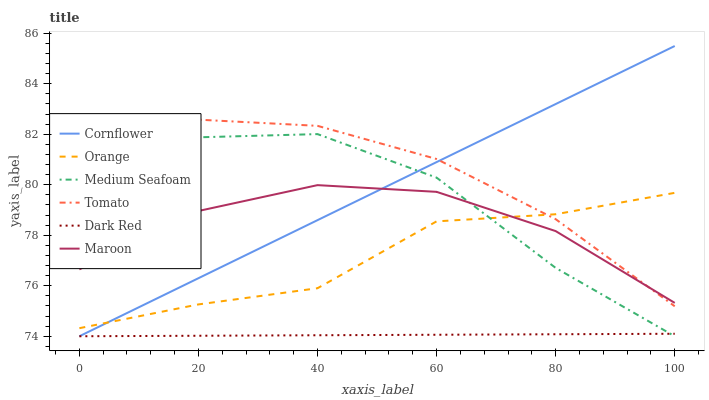Does Dark Red have the minimum area under the curve?
Answer yes or no. Yes. Does Tomato have the maximum area under the curve?
Answer yes or no. Yes. Does Cornflower have the minimum area under the curve?
Answer yes or no. No. Does Cornflower have the maximum area under the curve?
Answer yes or no. No. Is Dark Red the smoothest?
Answer yes or no. Yes. Is Medium Seafoam the roughest?
Answer yes or no. Yes. Is Cornflower the smoothest?
Answer yes or no. No. Is Cornflower the roughest?
Answer yes or no. No. Does Maroon have the lowest value?
Answer yes or no. No. Does Cornflower have the highest value?
Answer yes or no. Yes. Does Dark Red have the highest value?
Answer yes or no. No. Is Medium Seafoam less than Tomato?
Answer yes or no. Yes. Is Orange greater than Dark Red?
Answer yes or no. Yes. Does Medium Seafoam intersect Orange?
Answer yes or no. Yes. Is Medium Seafoam less than Orange?
Answer yes or no. No. Is Medium Seafoam greater than Orange?
Answer yes or no. No. Does Medium Seafoam intersect Tomato?
Answer yes or no. No. 